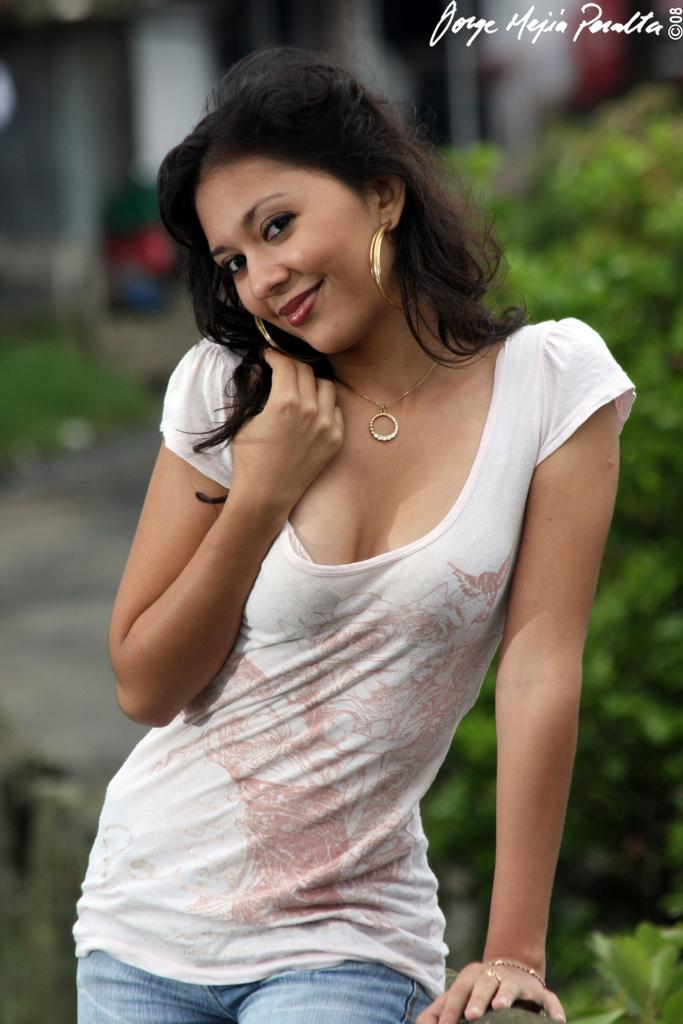What is the main subject of the image? There is a woman standing in the image. What else can be seen in the image besides the woman? There are plants visible in the image. What type of meal is the woman eating in the image? There is no indication of a meal in the image. 